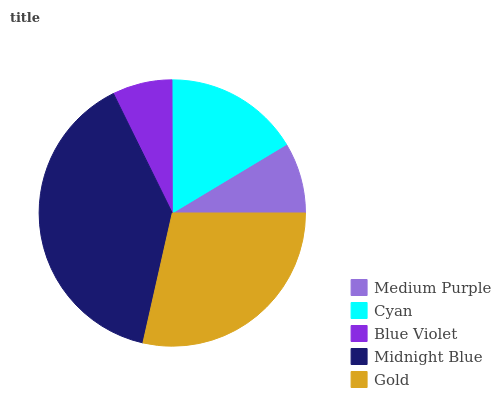Is Blue Violet the minimum?
Answer yes or no. Yes. Is Midnight Blue the maximum?
Answer yes or no. Yes. Is Cyan the minimum?
Answer yes or no. No. Is Cyan the maximum?
Answer yes or no. No. Is Cyan greater than Medium Purple?
Answer yes or no. Yes. Is Medium Purple less than Cyan?
Answer yes or no. Yes. Is Medium Purple greater than Cyan?
Answer yes or no. No. Is Cyan less than Medium Purple?
Answer yes or no. No. Is Cyan the high median?
Answer yes or no. Yes. Is Cyan the low median?
Answer yes or no. Yes. Is Gold the high median?
Answer yes or no. No. Is Midnight Blue the low median?
Answer yes or no. No. 